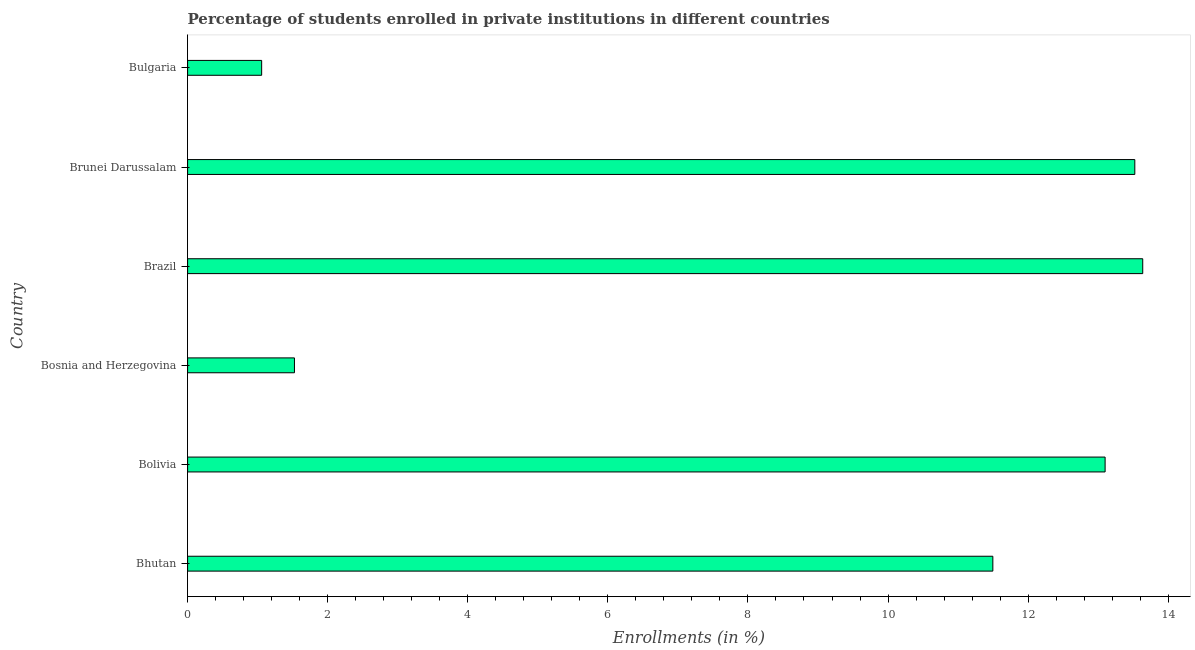Does the graph contain grids?
Make the answer very short. No. What is the title of the graph?
Your answer should be very brief. Percentage of students enrolled in private institutions in different countries. What is the label or title of the X-axis?
Make the answer very short. Enrollments (in %). What is the label or title of the Y-axis?
Provide a short and direct response. Country. What is the enrollments in private institutions in Bosnia and Herzegovina?
Offer a terse response. 1.53. Across all countries, what is the maximum enrollments in private institutions?
Ensure brevity in your answer.  13.64. Across all countries, what is the minimum enrollments in private institutions?
Your response must be concise. 1.06. In which country was the enrollments in private institutions maximum?
Provide a succinct answer. Brazil. What is the sum of the enrollments in private institutions?
Your response must be concise. 54.34. What is the difference between the enrollments in private institutions in Bhutan and Brazil?
Ensure brevity in your answer.  -2.14. What is the average enrollments in private institutions per country?
Provide a succinct answer. 9.06. What is the median enrollments in private institutions?
Provide a succinct answer. 12.3. In how many countries, is the enrollments in private institutions greater than 6.4 %?
Your answer should be compact. 4. What is the ratio of the enrollments in private institutions in Bosnia and Herzegovina to that in Bulgaria?
Give a very brief answer. 1.44. What is the difference between the highest and the second highest enrollments in private institutions?
Keep it short and to the point. 0.11. What is the difference between the highest and the lowest enrollments in private institutions?
Provide a succinct answer. 12.58. In how many countries, is the enrollments in private institutions greater than the average enrollments in private institutions taken over all countries?
Ensure brevity in your answer.  4. How many countries are there in the graph?
Provide a succinct answer. 6. What is the difference between two consecutive major ticks on the X-axis?
Offer a very short reply. 2. Are the values on the major ticks of X-axis written in scientific E-notation?
Offer a very short reply. No. What is the Enrollments (in %) of Bhutan?
Your answer should be compact. 11.5. What is the Enrollments (in %) in Bolivia?
Ensure brevity in your answer.  13.1. What is the Enrollments (in %) of Bosnia and Herzegovina?
Keep it short and to the point. 1.53. What is the Enrollments (in %) in Brazil?
Your answer should be very brief. 13.64. What is the Enrollments (in %) of Brunei Darussalam?
Give a very brief answer. 13.52. What is the Enrollments (in %) of Bulgaria?
Ensure brevity in your answer.  1.06. What is the difference between the Enrollments (in %) in Bhutan and Bolivia?
Offer a terse response. -1.6. What is the difference between the Enrollments (in %) in Bhutan and Bosnia and Herzegovina?
Ensure brevity in your answer.  9.97. What is the difference between the Enrollments (in %) in Bhutan and Brazil?
Keep it short and to the point. -2.14. What is the difference between the Enrollments (in %) in Bhutan and Brunei Darussalam?
Provide a succinct answer. -2.03. What is the difference between the Enrollments (in %) in Bhutan and Bulgaria?
Offer a terse response. 10.44. What is the difference between the Enrollments (in %) in Bolivia and Bosnia and Herzegovina?
Keep it short and to the point. 11.57. What is the difference between the Enrollments (in %) in Bolivia and Brazil?
Give a very brief answer. -0.54. What is the difference between the Enrollments (in %) in Bolivia and Brunei Darussalam?
Your answer should be compact. -0.42. What is the difference between the Enrollments (in %) in Bolivia and Bulgaria?
Ensure brevity in your answer.  12.04. What is the difference between the Enrollments (in %) in Bosnia and Herzegovina and Brazil?
Provide a succinct answer. -12.11. What is the difference between the Enrollments (in %) in Bosnia and Herzegovina and Brunei Darussalam?
Offer a terse response. -12. What is the difference between the Enrollments (in %) in Bosnia and Herzegovina and Bulgaria?
Your answer should be compact. 0.47. What is the difference between the Enrollments (in %) in Brazil and Brunei Darussalam?
Provide a succinct answer. 0.11. What is the difference between the Enrollments (in %) in Brazil and Bulgaria?
Ensure brevity in your answer.  12.58. What is the difference between the Enrollments (in %) in Brunei Darussalam and Bulgaria?
Your response must be concise. 12.47. What is the ratio of the Enrollments (in %) in Bhutan to that in Bolivia?
Offer a very short reply. 0.88. What is the ratio of the Enrollments (in %) in Bhutan to that in Bosnia and Herzegovina?
Your answer should be very brief. 7.54. What is the ratio of the Enrollments (in %) in Bhutan to that in Brazil?
Ensure brevity in your answer.  0.84. What is the ratio of the Enrollments (in %) in Bhutan to that in Brunei Darussalam?
Provide a short and direct response. 0.85. What is the ratio of the Enrollments (in %) in Bhutan to that in Bulgaria?
Your response must be concise. 10.87. What is the ratio of the Enrollments (in %) in Bolivia to that in Bosnia and Herzegovina?
Give a very brief answer. 8.59. What is the ratio of the Enrollments (in %) in Bolivia to that in Brazil?
Ensure brevity in your answer.  0.96. What is the ratio of the Enrollments (in %) in Bolivia to that in Brunei Darussalam?
Offer a very short reply. 0.97. What is the ratio of the Enrollments (in %) in Bolivia to that in Bulgaria?
Your answer should be very brief. 12.39. What is the ratio of the Enrollments (in %) in Bosnia and Herzegovina to that in Brazil?
Your answer should be compact. 0.11. What is the ratio of the Enrollments (in %) in Bosnia and Herzegovina to that in Brunei Darussalam?
Provide a succinct answer. 0.11. What is the ratio of the Enrollments (in %) in Bosnia and Herzegovina to that in Bulgaria?
Offer a very short reply. 1.44. What is the ratio of the Enrollments (in %) in Brazil to that in Brunei Darussalam?
Keep it short and to the point. 1.01. What is the ratio of the Enrollments (in %) in Brazil to that in Bulgaria?
Provide a succinct answer. 12.9. What is the ratio of the Enrollments (in %) in Brunei Darussalam to that in Bulgaria?
Give a very brief answer. 12.79. 